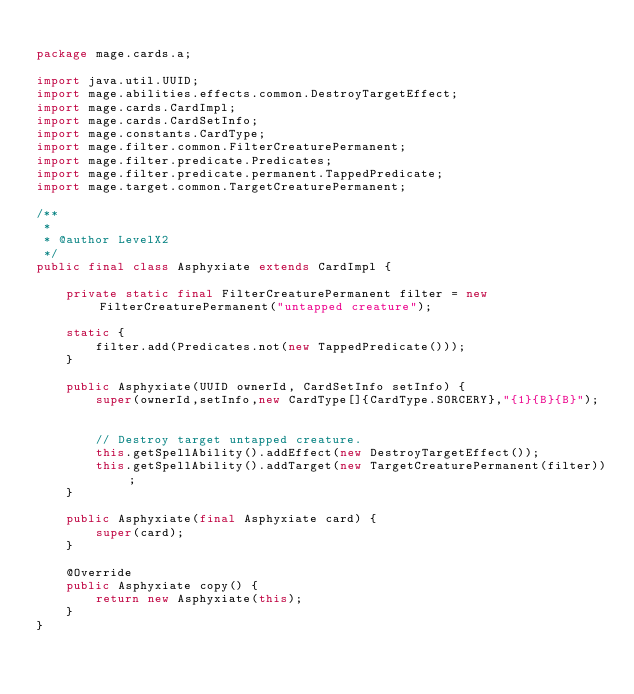Convert code to text. <code><loc_0><loc_0><loc_500><loc_500><_Java_>
package mage.cards.a;

import java.util.UUID;
import mage.abilities.effects.common.DestroyTargetEffect;
import mage.cards.CardImpl;
import mage.cards.CardSetInfo;
import mage.constants.CardType;
import mage.filter.common.FilterCreaturePermanent;
import mage.filter.predicate.Predicates;
import mage.filter.predicate.permanent.TappedPredicate;
import mage.target.common.TargetCreaturePermanent;

/**
 *
 * @author LevelX2
 */
public final class Asphyxiate extends CardImpl {

    private static final FilterCreaturePermanent filter = new FilterCreaturePermanent("untapped creature");
    
    static {
        filter.add(Predicates.not(new TappedPredicate()));
    }
    
    public Asphyxiate(UUID ownerId, CardSetInfo setInfo) {
        super(ownerId,setInfo,new CardType[]{CardType.SORCERY},"{1}{B}{B}");


        // Destroy target untapped creature.
        this.getSpellAbility().addEffect(new DestroyTargetEffect());
        this.getSpellAbility().addTarget(new TargetCreaturePermanent(filter));
    }

    public Asphyxiate(final Asphyxiate card) {
        super(card);
    }

    @Override
    public Asphyxiate copy() {
        return new Asphyxiate(this);
    }
}
</code> 